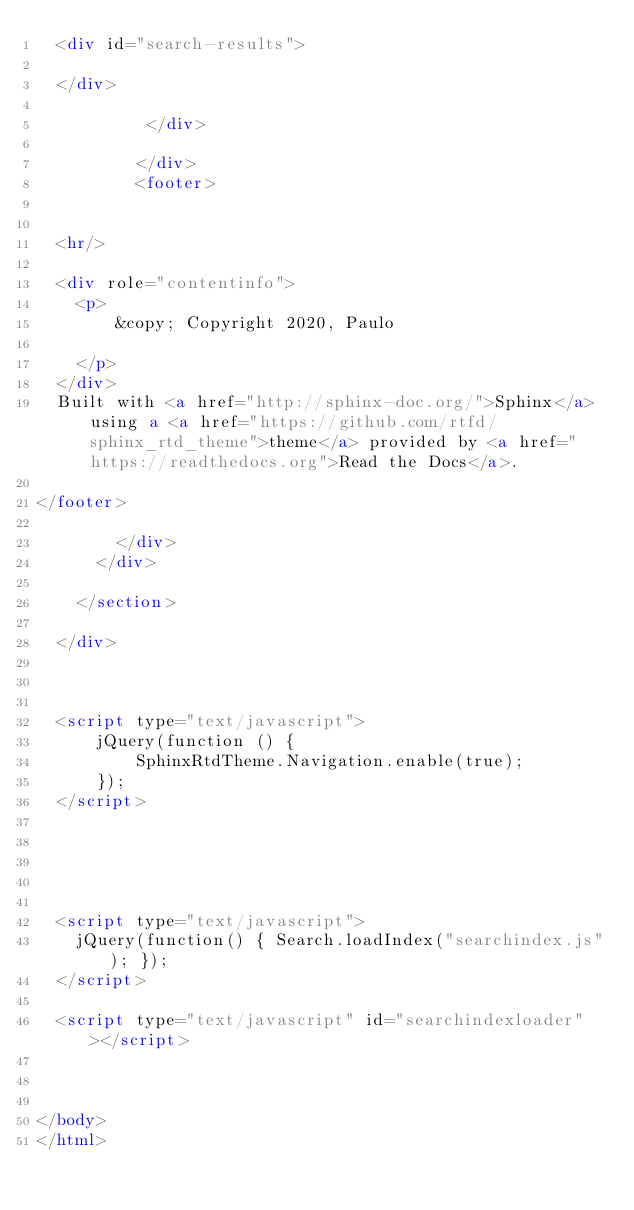Convert code to text. <code><loc_0><loc_0><loc_500><loc_500><_HTML_>  <div id="search-results">
  
  </div>

           </div>
           
          </div>
          <footer>
  

  <hr/>

  <div role="contentinfo">
    <p>
        &copy; Copyright 2020, Paulo

    </p>
  </div>
  Built with <a href="http://sphinx-doc.org/">Sphinx</a> using a <a href="https://github.com/rtfd/sphinx_rtd_theme">theme</a> provided by <a href="https://readthedocs.org">Read the Docs</a>. 

</footer>

        </div>
      </div>

    </section>

  </div>
  


  <script type="text/javascript">
      jQuery(function () {
          SphinxRtdTheme.Navigation.enable(true);
      });
  </script>

  
  
    
  
  <script type="text/javascript">
    jQuery(function() { Search.loadIndex("searchindex.js"); });
  </script>
  
  <script type="text/javascript" id="searchindexloader"></script>
   


</body>
</html></code> 